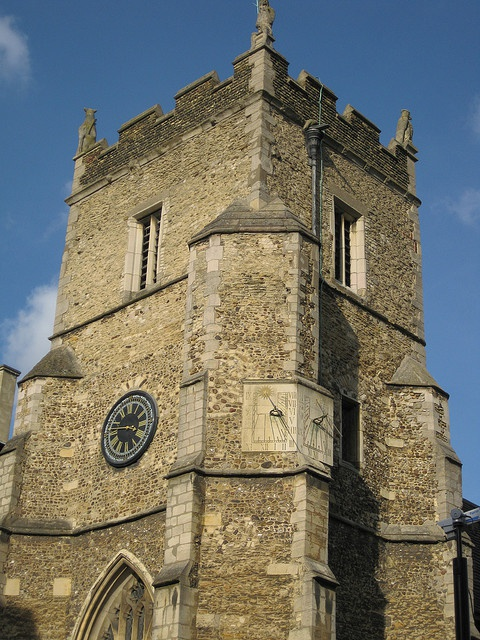Describe the objects in this image and their specific colors. I can see a clock in blue, black, gray, olive, and darkgray tones in this image. 